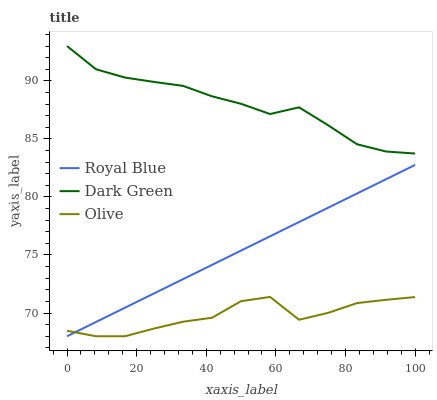Does Olive have the minimum area under the curve?
Answer yes or no. Yes. Does Dark Green have the maximum area under the curve?
Answer yes or no. Yes. Does Royal Blue have the minimum area under the curve?
Answer yes or no. No. Does Royal Blue have the maximum area under the curve?
Answer yes or no. No. Is Royal Blue the smoothest?
Answer yes or no. Yes. Is Olive the roughest?
Answer yes or no. Yes. Is Dark Green the smoothest?
Answer yes or no. No. Is Dark Green the roughest?
Answer yes or no. No. Does Olive have the lowest value?
Answer yes or no. Yes. Does Dark Green have the lowest value?
Answer yes or no. No. Does Dark Green have the highest value?
Answer yes or no. Yes. Does Royal Blue have the highest value?
Answer yes or no. No. Is Royal Blue less than Dark Green?
Answer yes or no. Yes. Is Dark Green greater than Royal Blue?
Answer yes or no. Yes. Does Royal Blue intersect Olive?
Answer yes or no. Yes. Is Royal Blue less than Olive?
Answer yes or no. No. Is Royal Blue greater than Olive?
Answer yes or no. No. Does Royal Blue intersect Dark Green?
Answer yes or no. No. 